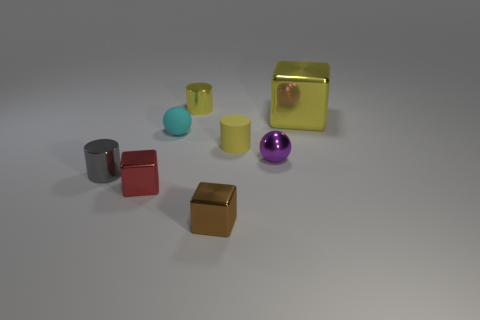Subtract all purple balls. How many balls are left? 1 Subtract all small shiny cubes. How many cubes are left? 1 Subtract 1 balls. How many balls are left? 1 Subtract all balls. How many objects are left? 6 Subtract all blue blocks. How many purple balls are left? 1 Subtract all yellow blocks. Subtract all red cylinders. How many blocks are left? 2 Subtract all tiny blue metallic spheres. Subtract all large yellow shiny objects. How many objects are left? 7 Add 1 tiny gray metallic cylinders. How many tiny gray metallic cylinders are left? 2 Add 4 purple metal balls. How many purple metal balls exist? 5 Add 1 tiny cyan spheres. How many objects exist? 9 